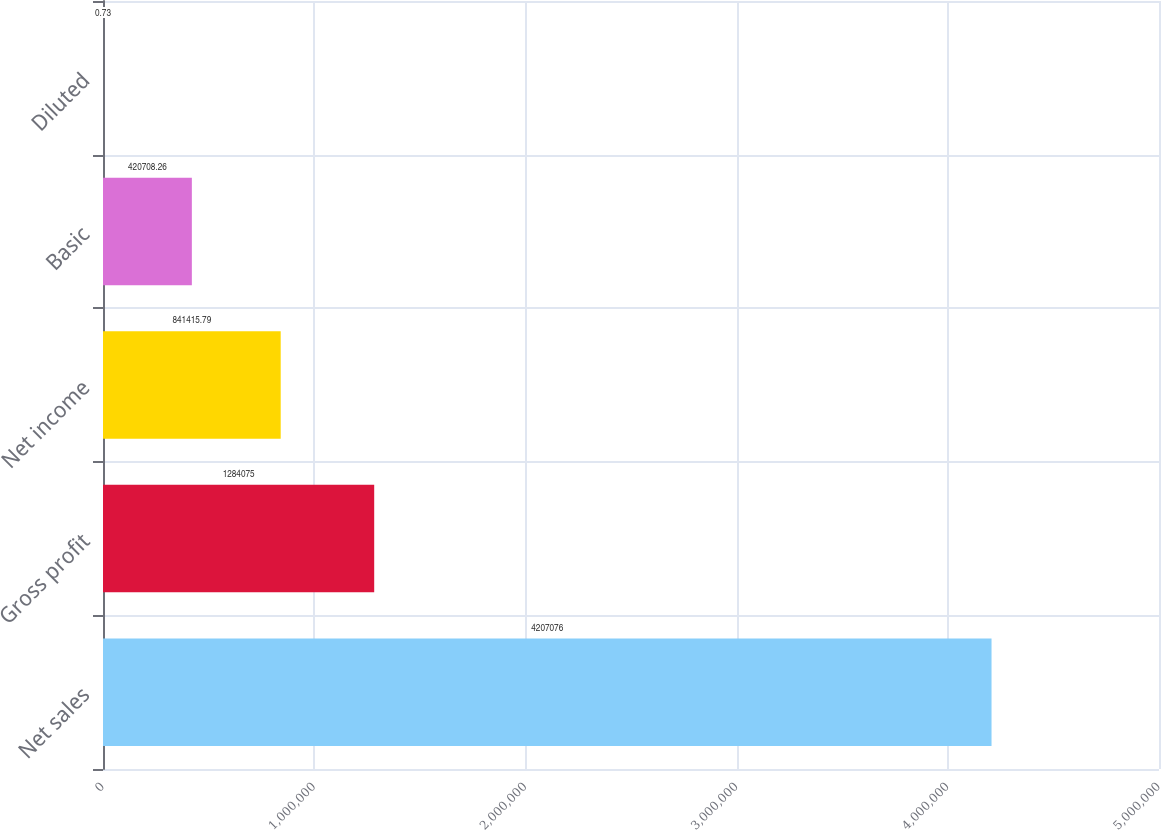Convert chart to OTSL. <chart><loc_0><loc_0><loc_500><loc_500><bar_chart><fcel>Net sales<fcel>Gross profit<fcel>Net income<fcel>Basic<fcel>Diluted<nl><fcel>4.20708e+06<fcel>1.28408e+06<fcel>841416<fcel>420708<fcel>0.73<nl></chart> 